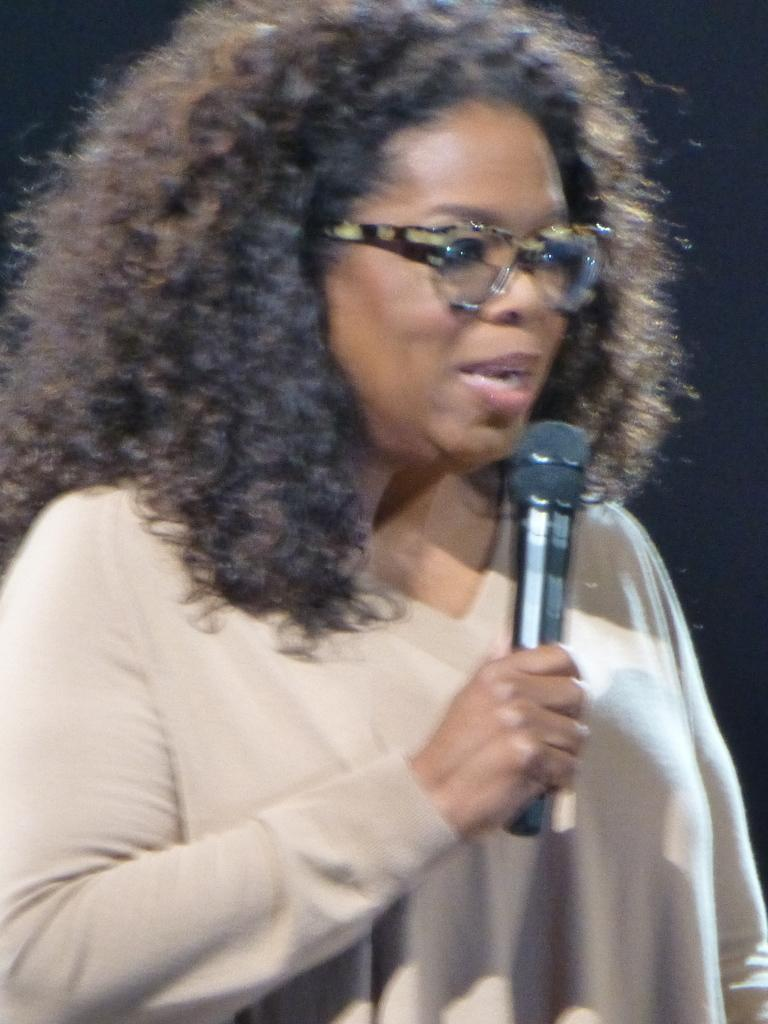Who is the main subject in the image? There is a woman in the image. What is the woman holding in her hand? The woman is holding a microphone with her hand. Can you describe any accessories the woman is wearing? The woman is wearing spectacles. What type of lead is the woman using to communicate with the spy in the image? There is no mention of a spy or any communication device in the image, so it is not possible to determine what type of lead the woman might be using. 